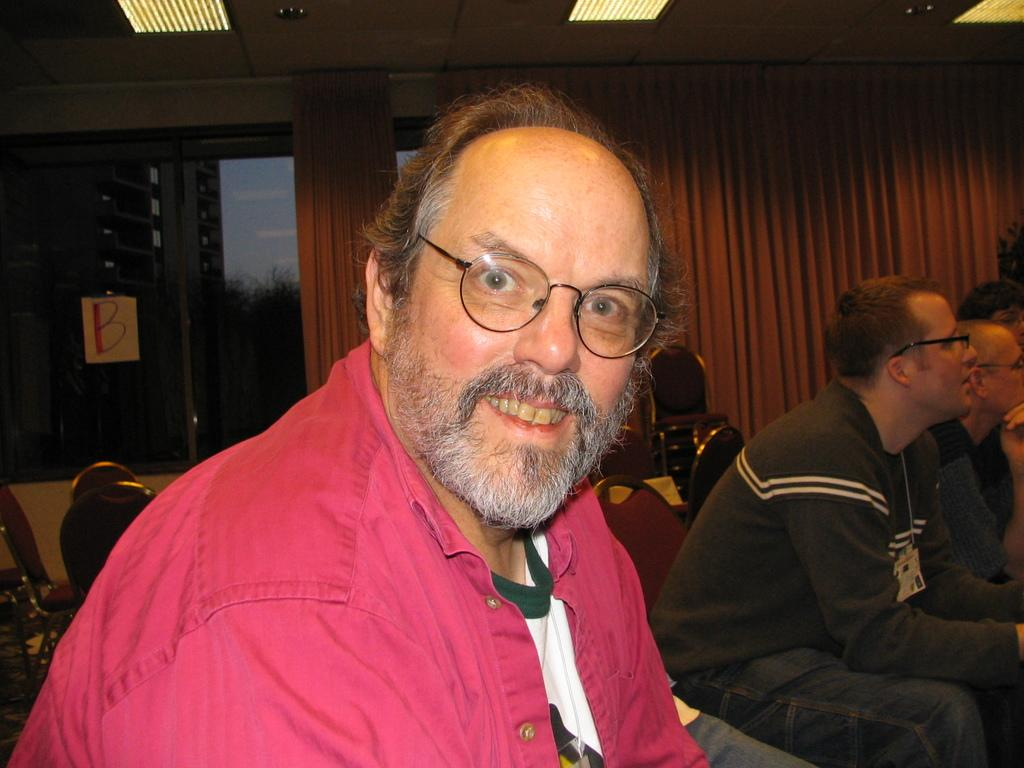What is the man in the image doing? The man is sitting in the image. What can be seen on the man's face? The man is wearing spectacles. What type of clothing is the man wearing? The man is wearing a t-shirt. Can you describe the people behind the man? There are other people sitting on chairs behind the man. What color is the ladybug on the man's t-shirt in the image? There is no ladybug present on the man's t-shirt in the image. What type of plastic material is used to make the chairs the people are sitting on? The provided facts do not mention the material used to make the chairs, so we cannot determine if plastic is used. 